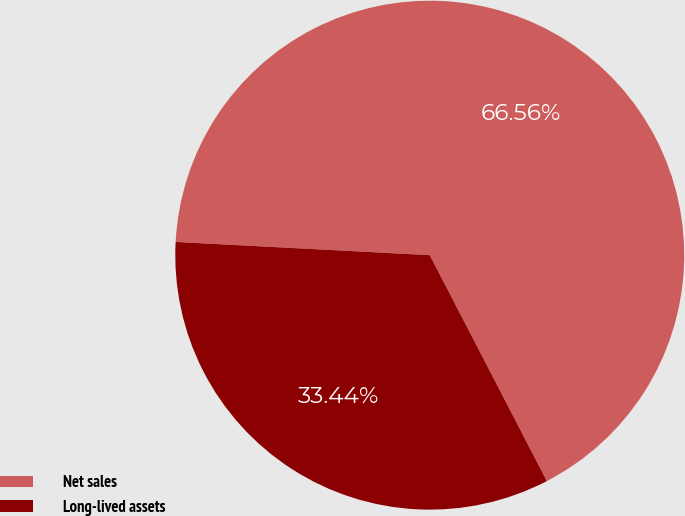<chart> <loc_0><loc_0><loc_500><loc_500><pie_chart><fcel>Net sales<fcel>Long-lived assets<nl><fcel>66.56%<fcel>33.44%<nl></chart> 